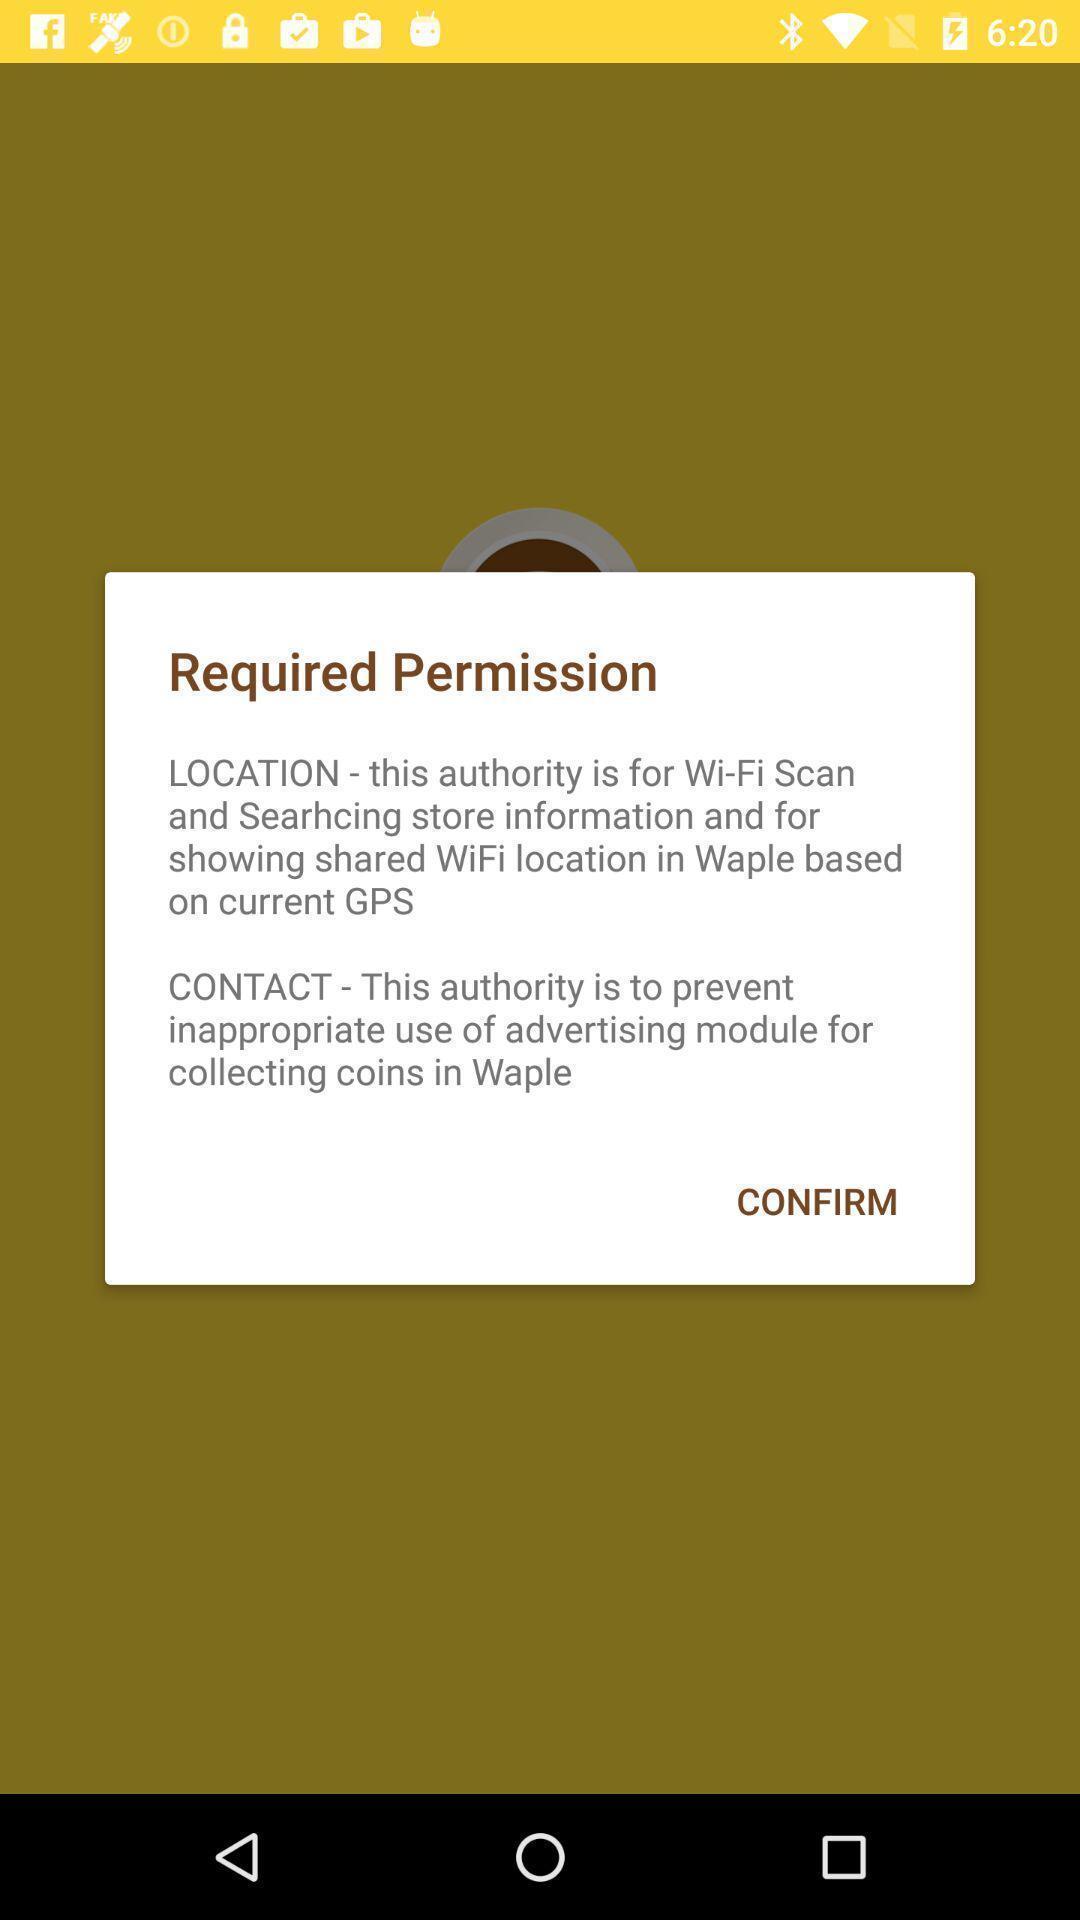Explain what's happening in this screen capture. Popup of permission in free wifi app. 